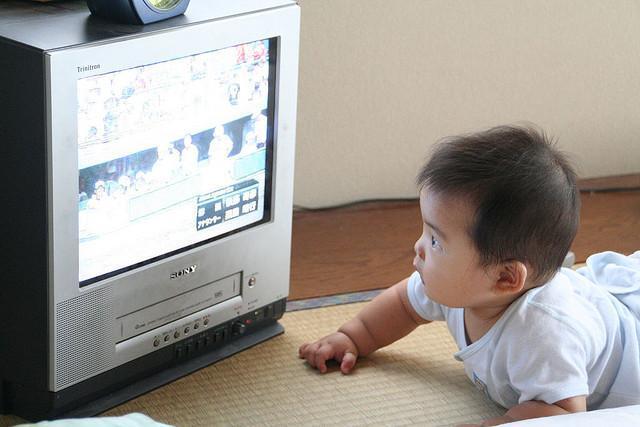How many elephants are in the grass?
Give a very brief answer. 0. 